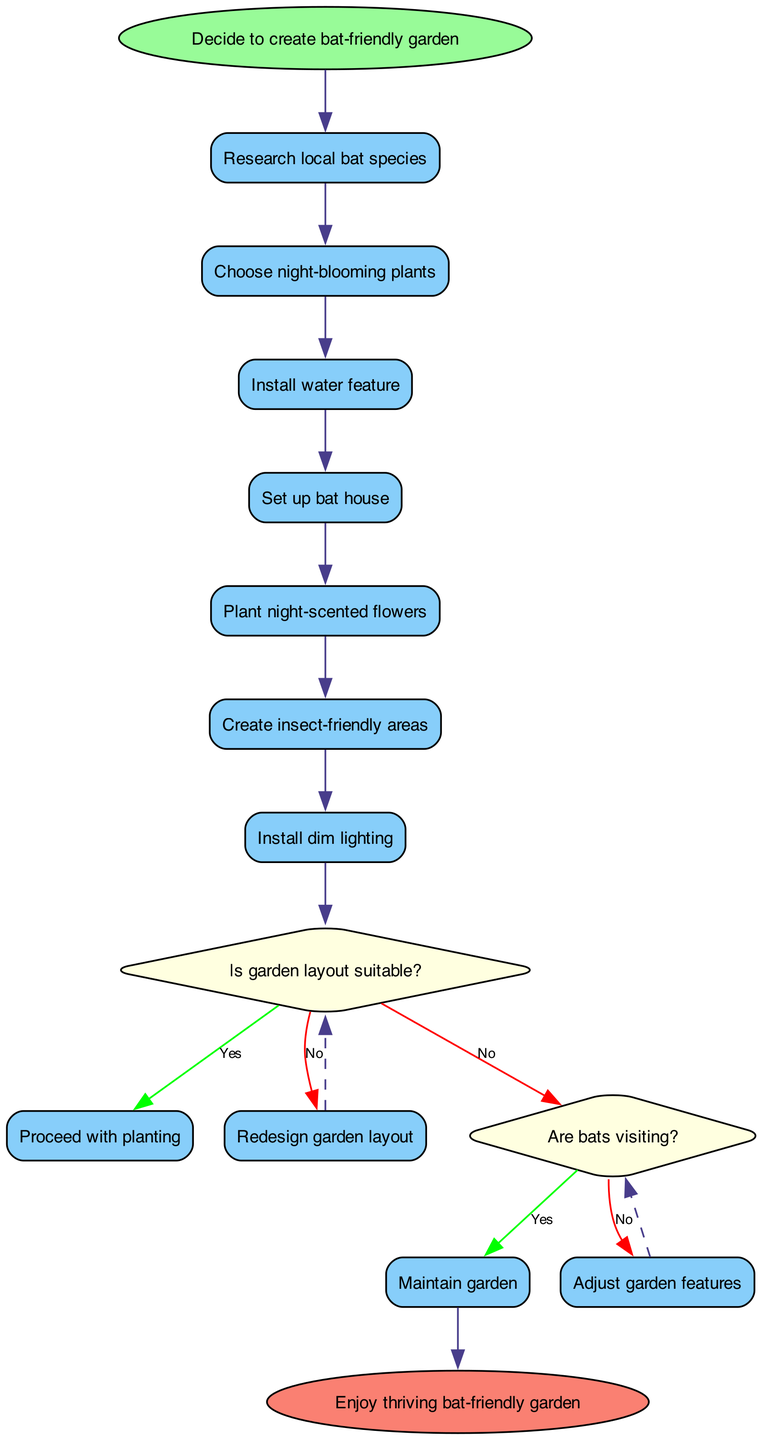What is the starting activity of the diagram? The starting activity is indicated by the start node, which is labeled as "Decide to create bat-friendly garden."
Answer: Decide to create bat-friendly garden How many activities are listed in the diagram? The diagram includes seven activities, which can be counted visually from the activity nodes.
Answer: 7 What comes after "Research local bat species"? Tracing the flow of the diagram, the next activity that follows is "Choose night-blooming plants."
Answer: Choose night-blooming plants What question is posed at the first decision node? The first decision node is presented with the question "Is garden layout suitable?" as seen in the diamond-shaped node.
Answer: Is garden layout suitable? If the garden layout is not suitable, what is the next step? From the decision node "Is garden layout suitable?", if the answer is 'no', the next step indicated is "Redesign garden layout."
Answer: Redesign garden layout What happens if bats are visiting the garden? The decision node "Are bats visiting?" leads to "Maintain garden" if the answer is 'yes', showing the maintenance step.
Answer: Maintain garden How many decision nodes are present in the diagram? The diagram contains two decision nodes, which can be determined by counting the diamond-shaped nodes in it.
Answer: 2 What is the final outcome of the process in the diagram? The end node indicates the final outcome, which is labeled as "Enjoy thriving bat-friendly garden."
Answer: Enjoy thriving bat-friendly garden 